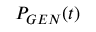Convert formula to latex. <formula><loc_0><loc_0><loc_500><loc_500>P _ { G E N } ( t )</formula> 